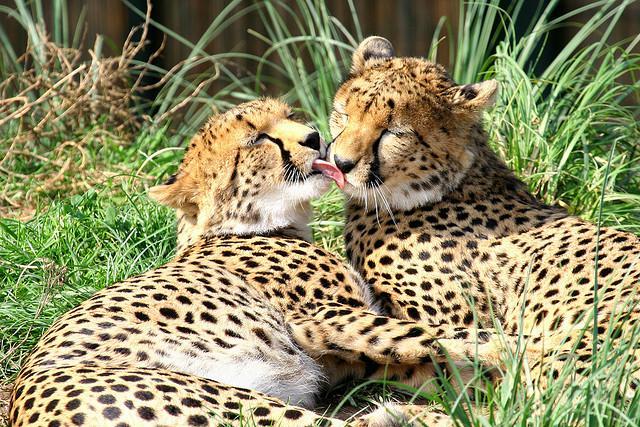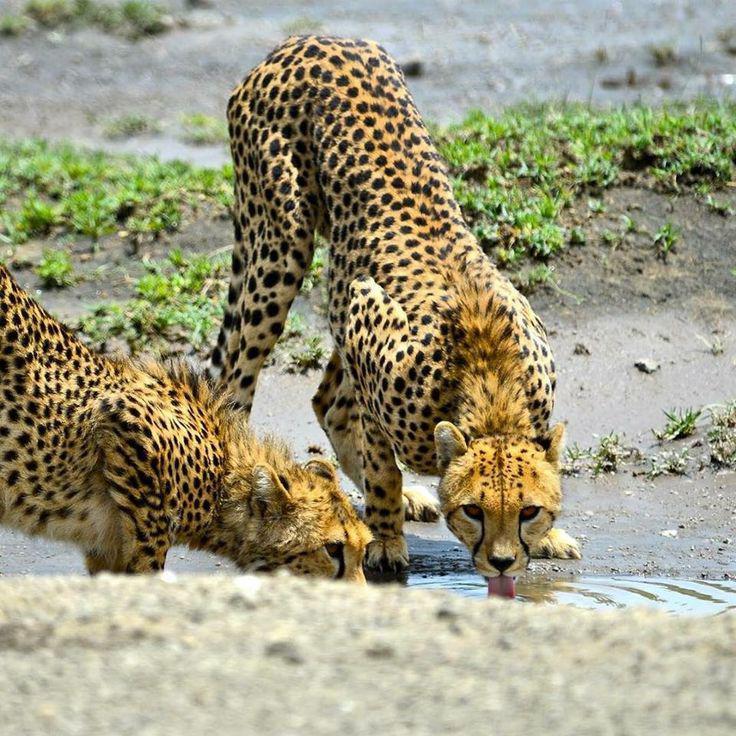The first image is the image on the left, the second image is the image on the right. For the images shown, is this caption "An image shows one spotted wild cat licking the face of another wild cat." true? Answer yes or no. Yes. The first image is the image on the left, the second image is the image on the right. Evaluate the accuracy of this statement regarding the images: "The left image contains a cheetah licking another cheetah.". Is it true? Answer yes or no. Yes. 